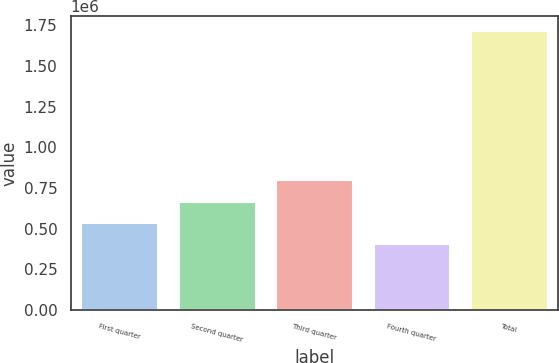Convert chart. <chart><loc_0><loc_0><loc_500><loc_500><bar_chart><fcel>First quarter<fcel>Second quarter<fcel>Third quarter<fcel>Fourth quarter<fcel>Total<nl><fcel>542249<fcel>673048<fcel>803848<fcel>411449<fcel>1.71944e+06<nl></chart> 